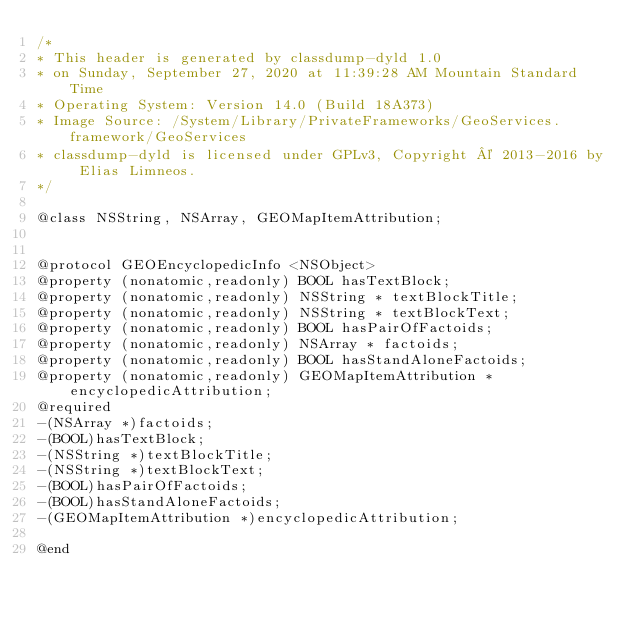<code> <loc_0><loc_0><loc_500><loc_500><_C_>/*
* This header is generated by classdump-dyld 1.0
* on Sunday, September 27, 2020 at 11:39:28 AM Mountain Standard Time
* Operating System: Version 14.0 (Build 18A373)
* Image Source: /System/Library/PrivateFrameworks/GeoServices.framework/GeoServices
* classdump-dyld is licensed under GPLv3, Copyright © 2013-2016 by Elias Limneos.
*/

@class NSString, NSArray, GEOMapItemAttribution;


@protocol GEOEncyclopedicInfo <NSObject>
@property (nonatomic,readonly) BOOL hasTextBlock; 
@property (nonatomic,readonly) NSString * textBlockTitle; 
@property (nonatomic,readonly) NSString * textBlockText; 
@property (nonatomic,readonly) BOOL hasPairOfFactoids; 
@property (nonatomic,readonly) NSArray * factoids; 
@property (nonatomic,readonly) BOOL hasStandAloneFactoids; 
@property (nonatomic,readonly) GEOMapItemAttribution * encyclopedicAttribution; 
@required
-(NSArray *)factoids;
-(BOOL)hasTextBlock;
-(NSString *)textBlockTitle;
-(NSString *)textBlockText;
-(BOOL)hasPairOfFactoids;
-(BOOL)hasStandAloneFactoids;
-(GEOMapItemAttribution *)encyclopedicAttribution;

@end

</code> 